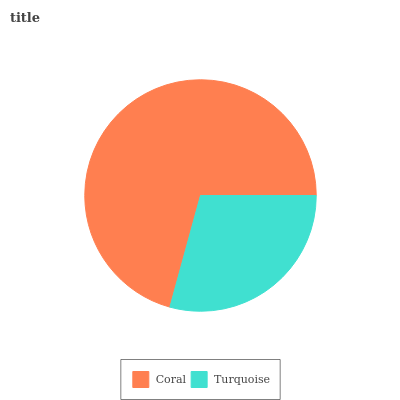Is Turquoise the minimum?
Answer yes or no. Yes. Is Coral the maximum?
Answer yes or no. Yes. Is Turquoise the maximum?
Answer yes or no. No. Is Coral greater than Turquoise?
Answer yes or no. Yes. Is Turquoise less than Coral?
Answer yes or no. Yes. Is Turquoise greater than Coral?
Answer yes or no. No. Is Coral less than Turquoise?
Answer yes or no. No. Is Coral the high median?
Answer yes or no. Yes. Is Turquoise the low median?
Answer yes or no. Yes. Is Turquoise the high median?
Answer yes or no. No. Is Coral the low median?
Answer yes or no. No. 